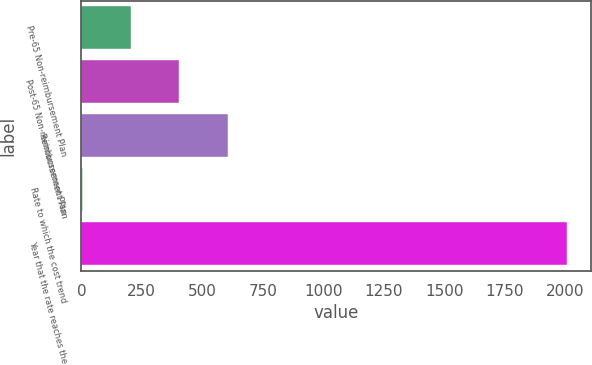<chart> <loc_0><loc_0><loc_500><loc_500><bar_chart><fcel>Pre-65 Non-reimbursement Plan<fcel>Post-65 Non-reimbursement Plan<fcel>Reimbursement Plan<fcel>Rate to which the cost trend<fcel>Year that the rate reaches the<nl><fcel>205.3<fcel>405.6<fcel>605.9<fcel>5<fcel>2008<nl></chart> 